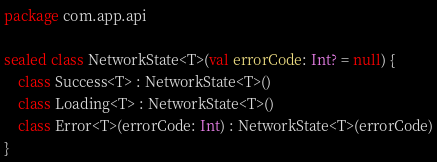Convert code to text. <code><loc_0><loc_0><loc_500><loc_500><_Kotlin_>package com.app.api

sealed class NetworkState<T>(val errorCode: Int? = null) {
    class Success<T> : NetworkState<T>()
    class Loading<T> : NetworkState<T>()
    class Error<T>(errorCode: Int) : NetworkState<T>(errorCode)
}
</code> 